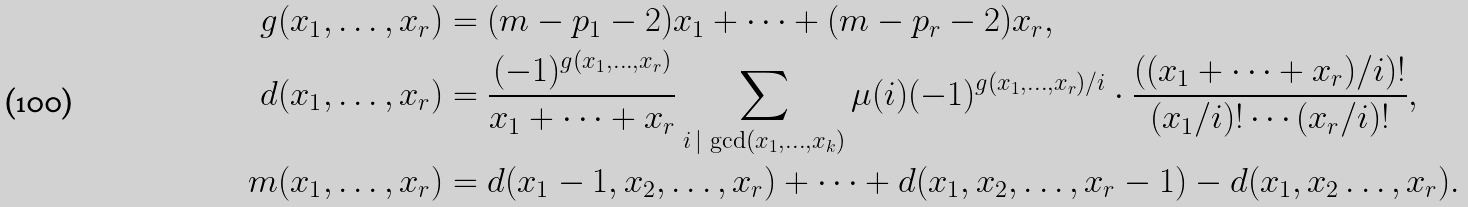Convert formula to latex. <formula><loc_0><loc_0><loc_500><loc_500>g ( x _ { 1 } , \dots , x _ { r } ) & = ( m - p _ { 1 } - 2 ) x _ { 1 } + \dots + ( m - p _ { r } - 2 ) x _ { r } , \\ d ( x _ { 1 } , \dots , x _ { r } ) & = \frac { ( - 1 ) ^ { g ( x _ { 1 } , \dots , x _ { r } ) } } { x _ { 1 } + \dots + x _ { r } } \sum _ { i \, | \, \gcd ( x _ { 1 } , \dots , x _ { k } ) } \mu ( i ) ( - 1 ) ^ { { g ( x _ { 1 } , \dots , x _ { r } ) } / { i } } \cdot \frac { \left ( ( x _ { 1 } + \dots + x _ { r } ) / i \right ) ! } { ( x _ { 1 } / i ) ! \cdots ( x _ { r } / i ) ! } , \\ m ( x _ { 1 } , \dots , x _ { r } ) & = d ( x _ { 1 } - 1 , x _ { 2 } , \dots , x _ { r } ) + \dots + d ( x _ { 1 } , x _ { 2 } , \dots , x _ { r } - 1 ) - d ( x _ { 1 } , x _ { 2 } \dots , x _ { r } ) .</formula> 